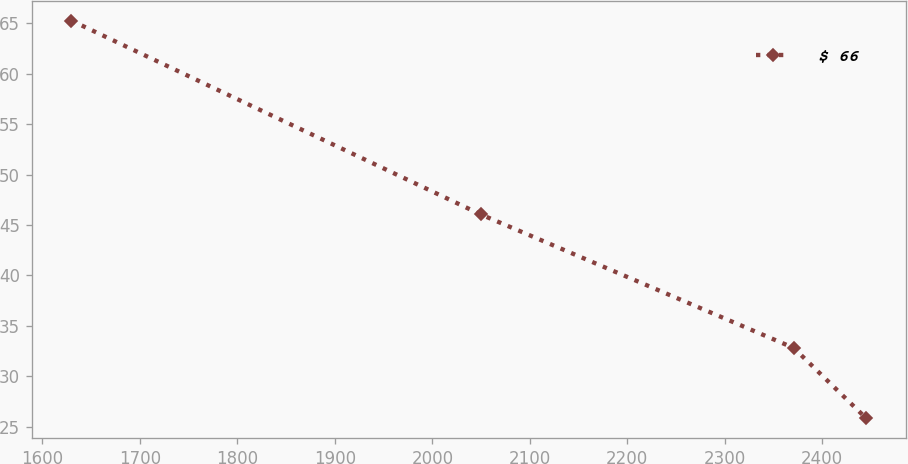Convert chart. <chart><loc_0><loc_0><loc_500><loc_500><line_chart><ecel><fcel>$ 66<nl><fcel>1629.7<fcel>65.27<nl><fcel>2049.76<fcel>46.05<nl><fcel>2370.69<fcel>32.82<nl><fcel>2445.06<fcel>25.84<nl></chart> 